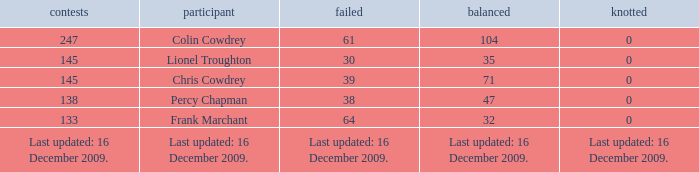Tell me the lost with tie of 0 and drawn of 47 38.0. 